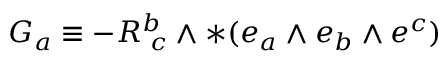<formula> <loc_0><loc_0><loc_500><loc_500>G _ { a } \equiv - R _ { \, c } ^ { b } \wedge * ( e _ { a } \wedge e _ { b } \wedge e ^ { c } )</formula> 